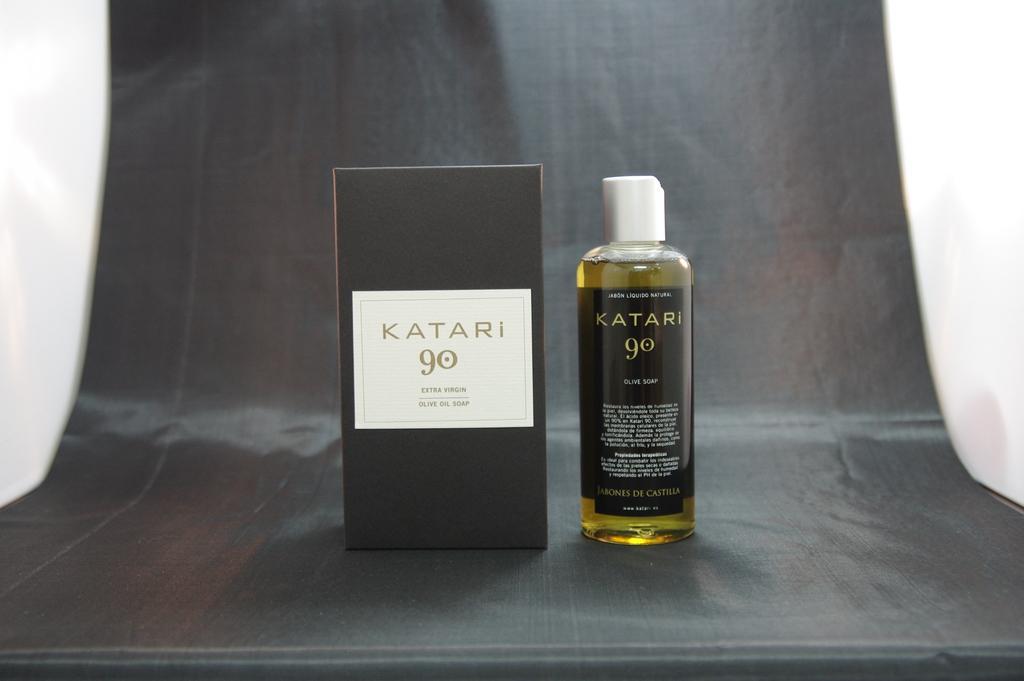Could you give a brief overview of what you see in this image? In this picture there is a black color box. Beside there is a bottle with yellow and black color label. Behind there is a black color curtain. 